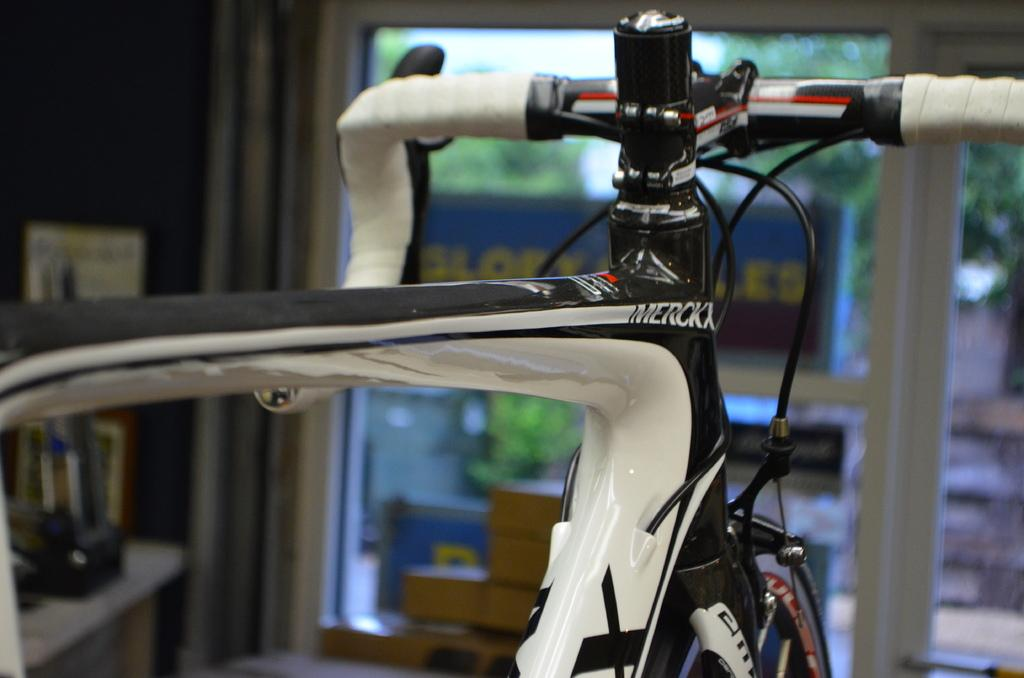What is the main object in the image? There is a bicycle in the image. What colors can be seen on the bicycle? The bicycle has white, black, and red colors. What type of structure is visible in the image? There is a glass window in the image. How would you describe the background of the image? The background of the image is blurred. Is there any steam coming from the bicycle in the image? No, there is no steam present in the image. What type of comb is being used to style the bicycle's handlebars in the image? There is no comb present in the image, as it features a bicycle and a glass window. 